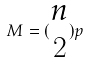Convert formula to latex. <formula><loc_0><loc_0><loc_500><loc_500>M = ( \begin{matrix} n \\ 2 \end{matrix} ) p</formula> 